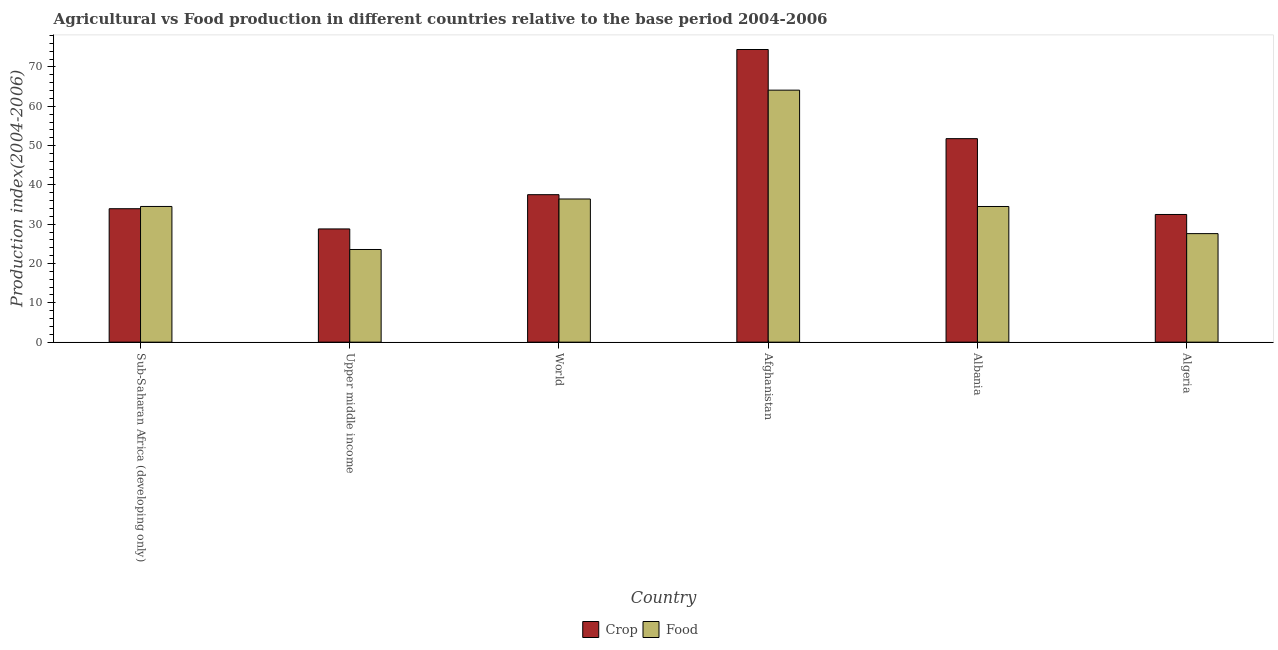How many different coloured bars are there?
Offer a very short reply. 2. Are the number of bars on each tick of the X-axis equal?
Ensure brevity in your answer.  Yes. What is the label of the 2nd group of bars from the left?
Ensure brevity in your answer.  Upper middle income. What is the crop production index in Afghanistan?
Give a very brief answer. 74.45. Across all countries, what is the maximum food production index?
Provide a succinct answer. 64.11. Across all countries, what is the minimum food production index?
Your answer should be compact. 23.57. In which country was the food production index maximum?
Your answer should be compact. Afghanistan. In which country was the crop production index minimum?
Your answer should be very brief. Upper middle income. What is the total crop production index in the graph?
Your answer should be very brief. 258.97. What is the difference between the crop production index in Afghanistan and that in Albania?
Your answer should be very brief. 22.68. What is the difference between the crop production index in Algeria and the food production index in Upper middle income?
Your answer should be very brief. 8.91. What is the average crop production index per country?
Keep it short and to the point. 43.16. What is the difference between the crop production index and food production index in Upper middle income?
Make the answer very short. 5.23. What is the ratio of the crop production index in Albania to that in Upper middle income?
Offer a terse response. 1.8. Is the crop production index in Algeria less than that in World?
Offer a terse response. Yes. Is the difference between the food production index in Algeria and Sub-Saharan Africa (developing only) greater than the difference between the crop production index in Algeria and Sub-Saharan Africa (developing only)?
Give a very brief answer. No. What is the difference between the highest and the second highest food production index?
Provide a short and direct response. 27.69. What is the difference between the highest and the lowest crop production index?
Provide a succinct answer. 45.64. In how many countries, is the crop production index greater than the average crop production index taken over all countries?
Offer a very short reply. 2. What does the 2nd bar from the left in Sub-Saharan Africa (developing only) represents?
Provide a succinct answer. Food. What does the 2nd bar from the right in Algeria represents?
Provide a short and direct response. Crop. Are all the bars in the graph horizontal?
Your response must be concise. No. What is the difference between two consecutive major ticks on the Y-axis?
Give a very brief answer. 10. Are the values on the major ticks of Y-axis written in scientific E-notation?
Your response must be concise. No. Does the graph contain any zero values?
Offer a very short reply. No. How many legend labels are there?
Provide a succinct answer. 2. What is the title of the graph?
Ensure brevity in your answer.  Agricultural vs Food production in different countries relative to the base period 2004-2006. What is the label or title of the Y-axis?
Keep it short and to the point. Production index(2004-2006). What is the Production index(2004-2006) in Crop in Sub-Saharan Africa (developing only)?
Offer a very short reply. 33.95. What is the Production index(2004-2006) of Food in Sub-Saharan Africa (developing only)?
Provide a short and direct response. 34.52. What is the Production index(2004-2006) of Crop in Upper middle income?
Keep it short and to the point. 28.81. What is the Production index(2004-2006) of Food in Upper middle income?
Ensure brevity in your answer.  23.57. What is the Production index(2004-2006) in Crop in World?
Keep it short and to the point. 37.52. What is the Production index(2004-2006) in Food in World?
Your answer should be compact. 36.42. What is the Production index(2004-2006) of Crop in Afghanistan?
Ensure brevity in your answer.  74.45. What is the Production index(2004-2006) in Food in Afghanistan?
Provide a succinct answer. 64.11. What is the Production index(2004-2006) in Crop in Albania?
Your answer should be compact. 51.77. What is the Production index(2004-2006) of Food in Albania?
Provide a short and direct response. 34.51. What is the Production index(2004-2006) in Crop in Algeria?
Offer a terse response. 32.48. What is the Production index(2004-2006) in Food in Algeria?
Your response must be concise. 27.61. Across all countries, what is the maximum Production index(2004-2006) of Crop?
Provide a succinct answer. 74.45. Across all countries, what is the maximum Production index(2004-2006) in Food?
Give a very brief answer. 64.11. Across all countries, what is the minimum Production index(2004-2006) of Crop?
Give a very brief answer. 28.81. Across all countries, what is the minimum Production index(2004-2006) in Food?
Offer a very short reply. 23.57. What is the total Production index(2004-2006) of Crop in the graph?
Keep it short and to the point. 258.97. What is the total Production index(2004-2006) of Food in the graph?
Offer a terse response. 220.74. What is the difference between the Production index(2004-2006) of Crop in Sub-Saharan Africa (developing only) and that in Upper middle income?
Give a very brief answer. 5.14. What is the difference between the Production index(2004-2006) in Food in Sub-Saharan Africa (developing only) and that in Upper middle income?
Give a very brief answer. 10.95. What is the difference between the Production index(2004-2006) in Crop in Sub-Saharan Africa (developing only) and that in World?
Offer a very short reply. -3.57. What is the difference between the Production index(2004-2006) of Food in Sub-Saharan Africa (developing only) and that in World?
Your response must be concise. -1.9. What is the difference between the Production index(2004-2006) of Crop in Sub-Saharan Africa (developing only) and that in Afghanistan?
Your answer should be very brief. -40.5. What is the difference between the Production index(2004-2006) of Food in Sub-Saharan Africa (developing only) and that in Afghanistan?
Offer a terse response. -29.59. What is the difference between the Production index(2004-2006) in Crop in Sub-Saharan Africa (developing only) and that in Albania?
Offer a very short reply. -17.82. What is the difference between the Production index(2004-2006) of Food in Sub-Saharan Africa (developing only) and that in Albania?
Your answer should be compact. 0.01. What is the difference between the Production index(2004-2006) in Crop in Sub-Saharan Africa (developing only) and that in Algeria?
Make the answer very short. 1.47. What is the difference between the Production index(2004-2006) of Food in Sub-Saharan Africa (developing only) and that in Algeria?
Give a very brief answer. 6.91. What is the difference between the Production index(2004-2006) in Crop in Upper middle income and that in World?
Give a very brief answer. -8.71. What is the difference between the Production index(2004-2006) in Food in Upper middle income and that in World?
Ensure brevity in your answer.  -12.85. What is the difference between the Production index(2004-2006) of Crop in Upper middle income and that in Afghanistan?
Provide a succinct answer. -45.64. What is the difference between the Production index(2004-2006) in Food in Upper middle income and that in Afghanistan?
Provide a short and direct response. -40.54. What is the difference between the Production index(2004-2006) of Crop in Upper middle income and that in Albania?
Provide a succinct answer. -22.96. What is the difference between the Production index(2004-2006) in Food in Upper middle income and that in Albania?
Provide a succinct answer. -10.94. What is the difference between the Production index(2004-2006) of Crop in Upper middle income and that in Algeria?
Provide a succinct answer. -3.67. What is the difference between the Production index(2004-2006) in Food in Upper middle income and that in Algeria?
Your response must be concise. -4.04. What is the difference between the Production index(2004-2006) in Crop in World and that in Afghanistan?
Keep it short and to the point. -36.93. What is the difference between the Production index(2004-2006) of Food in World and that in Afghanistan?
Provide a succinct answer. -27.69. What is the difference between the Production index(2004-2006) of Crop in World and that in Albania?
Your answer should be compact. -14.25. What is the difference between the Production index(2004-2006) in Food in World and that in Albania?
Offer a very short reply. 1.91. What is the difference between the Production index(2004-2006) of Crop in World and that in Algeria?
Give a very brief answer. 5.04. What is the difference between the Production index(2004-2006) of Food in World and that in Algeria?
Offer a terse response. 8.81. What is the difference between the Production index(2004-2006) in Crop in Afghanistan and that in Albania?
Ensure brevity in your answer.  22.68. What is the difference between the Production index(2004-2006) in Food in Afghanistan and that in Albania?
Your answer should be very brief. 29.6. What is the difference between the Production index(2004-2006) of Crop in Afghanistan and that in Algeria?
Make the answer very short. 41.97. What is the difference between the Production index(2004-2006) of Food in Afghanistan and that in Algeria?
Offer a very short reply. 36.5. What is the difference between the Production index(2004-2006) in Crop in Albania and that in Algeria?
Make the answer very short. 19.29. What is the difference between the Production index(2004-2006) of Food in Albania and that in Algeria?
Offer a terse response. 6.9. What is the difference between the Production index(2004-2006) of Crop in Sub-Saharan Africa (developing only) and the Production index(2004-2006) of Food in Upper middle income?
Offer a terse response. 10.38. What is the difference between the Production index(2004-2006) of Crop in Sub-Saharan Africa (developing only) and the Production index(2004-2006) of Food in World?
Offer a terse response. -2.47. What is the difference between the Production index(2004-2006) in Crop in Sub-Saharan Africa (developing only) and the Production index(2004-2006) in Food in Afghanistan?
Provide a succinct answer. -30.16. What is the difference between the Production index(2004-2006) in Crop in Sub-Saharan Africa (developing only) and the Production index(2004-2006) in Food in Albania?
Ensure brevity in your answer.  -0.56. What is the difference between the Production index(2004-2006) of Crop in Sub-Saharan Africa (developing only) and the Production index(2004-2006) of Food in Algeria?
Your answer should be very brief. 6.34. What is the difference between the Production index(2004-2006) of Crop in Upper middle income and the Production index(2004-2006) of Food in World?
Your response must be concise. -7.62. What is the difference between the Production index(2004-2006) of Crop in Upper middle income and the Production index(2004-2006) of Food in Afghanistan?
Give a very brief answer. -35.3. What is the difference between the Production index(2004-2006) of Crop in Upper middle income and the Production index(2004-2006) of Food in Albania?
Keep it short and to the point. -5.7. What is the difference between the Production index(2004-2006) of Crop in Upper middle income and the Production index(2004-2006) of Food in Algeria?
Keep it short and to the point. 1.2. What is the difference between the Production index(2004-2006) in Crop in World and the Production index(2004-2006) in Food in Afghanistan?
Offer a terse response. -26.59. What is the difference between the Production index(2004-2006) of Crop in World and the Production index(2004-2006) of Food in Albania?
Your answer should be compact. 3.01. What is the difference between the Production index(2004-2006) of Crop in World and the Production index(2004-2006) of Food in Algeria?
Provide a short and direct response. 9.91. What is the difference between the Production index(2004-2006) in Crop in Afghanistan and the Production index(2004-2006) in Food in Albania?
Make the answer very short. 39.94. What is the difference between the Production index(2004-2006) in Crop in Afghanistan and the Production index(2004-2006) in Food in Algeria?
Your response must be concise. 46.84. What is the difference between the Production index(2004-2006) of Crop in Albania and the Production index(2004-2006) of Food in Algeria?
Keep it short and to the point. 24.16. What is the average Production index(2004-2006) of Crop per country?
Your answer should be compact. 43.16. What is the average Production index(2004-2006) of Food per country?
Offer a very short reply. 36.79. What is the difference between the Production index(2004-2006) of Crop and Production index(2004-2006) of Food in Sub-Saharan Africa (developing only)?
Offer a very short reply. -0.57. What is the difference between the Production index(2004-2006) of Crop and Production index(2004-2006) of Food in Upper middle income?
Make the answer very short. 5.23. What is the difference between the Production index(2004-2006) in Crop and Production index(2004-2006) in Food in World?
Offer a terse response. 1.1. What is the difference between the Production index(2004-2006) of Crop and Production index(2004-2006) of Food in Afghanistan?
Your response must be concise. 10.34. What is the difference between the Production index(2004-2006) in Crop and Production index(2004-2006) in Food in Albania?
Keep it short and to the point. 17.26. What is the difference between the Production index(2004-2006) in Crop and Production index(2004-2006) in Food in Algeria?
Provide a short and direct response. 4.87. What is the ratio of the Production index(2004-2006) in Crop in Sub-Saharan Africa (developing only) to that in Upper middle income?
Offer a terse response. 1.18. What is the ratio of the Production index(2004-2006) of Food in Sub-Saharan Africa (developing only) to that in Upper middle income?
Offer a terse response. 1.46. What is the ratio of the Production index(2004-2006) in Crop in Sub-Saharan Africa (developing only) to that in World?
Keep it short and to the point. 0.9. What is the ratio of the Production index(2004-2006) in Food in Sub-Saharan Africa (developing only) to that in World?
Your answer should be very brief. 0.95. What is the ratio of the Production index(2004-2006) of Crop in Sub-Saharan Africa (developing only) to that in Afghanistan?
Keep it short and to the point. 0.46. What is the ratio of the Production index(2004-2006) of Food in Sub-Saharan Africa (developing only) to that in Afghanistan?
Keep it short and to the point. 0.54. What is the ratio of the Production index(2004-2006) of Crop in Sub-Saharan Africa (developing only) to that in Albania?
Provide a short and direct response. 0.66. What is the ratio of the Production index(2004-2006) of Food in Sub-Saharan Africa (developing only) to that in Albania?
Give a very brief answer. 1. What is the ratio of the Production index(2004-2006) in Crop in Sub-Saharan Africa (developing only) to that in Algeria?
Offer a very short reply. 1.05. What is the ratio of the Production index(2004-2006) of Food in Sub-Saharan Africa (developing only) to that in Algeria?
Give a very brief answer. 1.25. What is the ratio of the Production index(2004-2006) in Crop in Upper middle income to that in World?
Make the answer very short. 0.77. What is the ratio of the Production index(2004-2006) of Food in Upper middle income to that in World?
Offer a terse response. 0.65. What is the ratio of the Production index(2004-2006) of Crop in Upper middle income to that in Afghanistan?
Ensure brevity in your answer.  0.39. What is the ratio of the Production index(2004-2006) of Food in Upper middle income to that in Afghanistan?
Offer a terse response. 0.37. What is the ratio of the Production index(2004-2006) of Crop in Upper middle income to that in Albania?
Keep it short and to the point. 0.56. What is the ratio of the Production index(2004-2006) in Food in Upper middle income to that in Albania?
Ensure brevity in your answer.  0.68. What is the ratio of the Production index(2004-2006) of Crop in Upper middle income to that in Algeria?
Make the answer very short. 0.89. What is the ratio of the Production index(2004-2006) of Food in Upper middle income to that in Algeria?
Ensure brevity in your answer.  0.85. What is the ratio of the Production index(2004-2006) in Crop in World to that in Afghanistan?
Give a very brief answer. 0.5. What is the ratio of the Production index(2004-2006) of Food in World to that in Afghanistan?
Offer a very short reply. 0.57. What is the ratio of the Production index(2004-2006) of Crop in World to that in Albania?
Your response must be concise. 0.72. What is the ratio of the Production index(2004-2006) in Food in World to that in Albania?
Make the answer very short. 1.06. What is the ratio of the Production index(2004-2006) of Crop in World to that in Algeria?
Offer a terse response. 1.16. What is the ratio of the Production index(2004-2006) of Food in World to that in Algeria?
Your response must be concise. 1.32. What is the ratio of the Production index(2004-2006) in Crop in Afghanistan to that in Albania?
Make the answer very short. 1.44. What is the ratio of the Production index(2004-2006) in Food in Afghanistan to that in Albania?
Your response must be concise. 1.86. What is the ratio of the Production index(2004-2006) in Crop in Afghanistan to that in Algeria?
Your answer should be very brief. 2.29. What is the ratio of the Production index(2004-2006) in Food in Afghanistan to that in Algeria?
Give a very brief answer. 2.32. What is the ratio of the Production index(2004-2006) in Crop in Albania to that in Algeria?
Your answer should be compact. 1.59. What is the ratio of the Production index(2004-2006) in Food in Albania to that in Algeria?
Your answer should be very brief. 1.25. What is the difference between the highest and the second highest Production index(2004-2006) in Crop?
Ensure brevity in your answer.  22.68. What is the difference between the highest and the second highest Production index(2004-2006) in Food?
Give a very brief answer. 27.69. What is the difference between the highest and the lowest Production index(2004-2006) in Crop?
Provide a short and direct response. 45.64. What is the difference between the highest and the lowest Production index(2004-2006) in Food?
Make the answer very short. 40.54. 